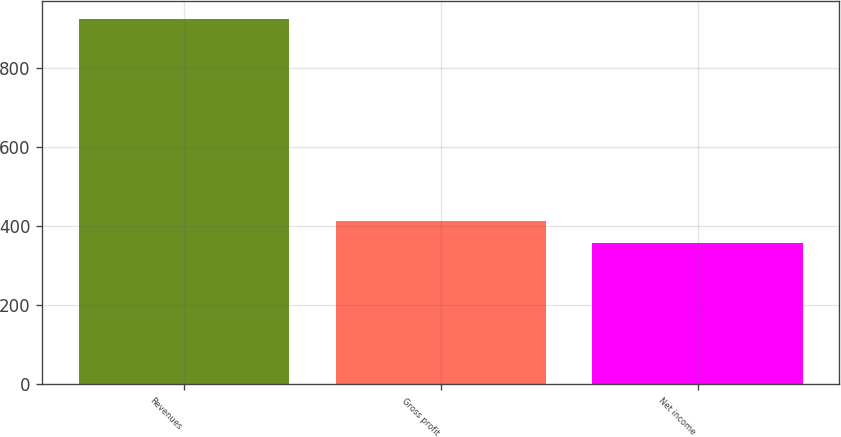Convert chart to OTSL. <chart><loc_0><loc_0><loc_500><loc_500><bar_chart><fcel>Revenues<fcel>Gross profit<fcel>Net income<nl><fcel>923<fcel>413.6<fcel>357<nl></chart> 